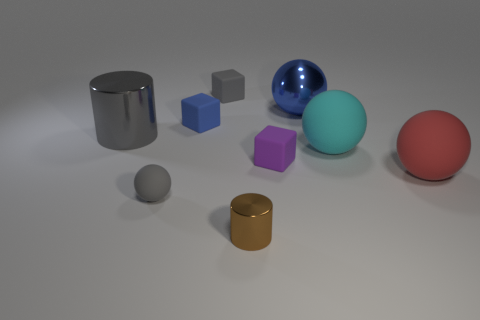There is a blue metallic sphere; is it the same size as the shiny cylinder on the right side of the large gray thing?
Give a very brief answer. No. How many other things are made of the same material as the brown cylinder?
Your answer should be compact. 2. The shiny object that is both right of the gray metal cylinder and left of the blue metallic thing is what color?
Keep it short and to the point. Brown. Do the cylinder behind the small metallic cylinder and the blue thing right of the small brown thing have the same material?
Provide a short and direct response. Yes. There is a metal thing that is right of the brown metal cylinder; does it have the same size as the large cyan sphere?
Your response must be concise. Yes. There is a big metallic ball; does it have the same color as the large rubber thing in front of the cyan matte sphere?
Your answer should be very brief. No. What shape is the tiny rubber thing that is the same color as the large metal sphere?
Give a very brief answer. Cube. What is the shape of the purple rubber object?
Ensure brevity in your answer.  Cube. Is the color of the tiny cylinder the same as the large metal ball?
Offer a terse response. No. What number of things are either matte objects that are in front of the cyan matte object or small blue matte blocks?
Your response must be concise. 4. 